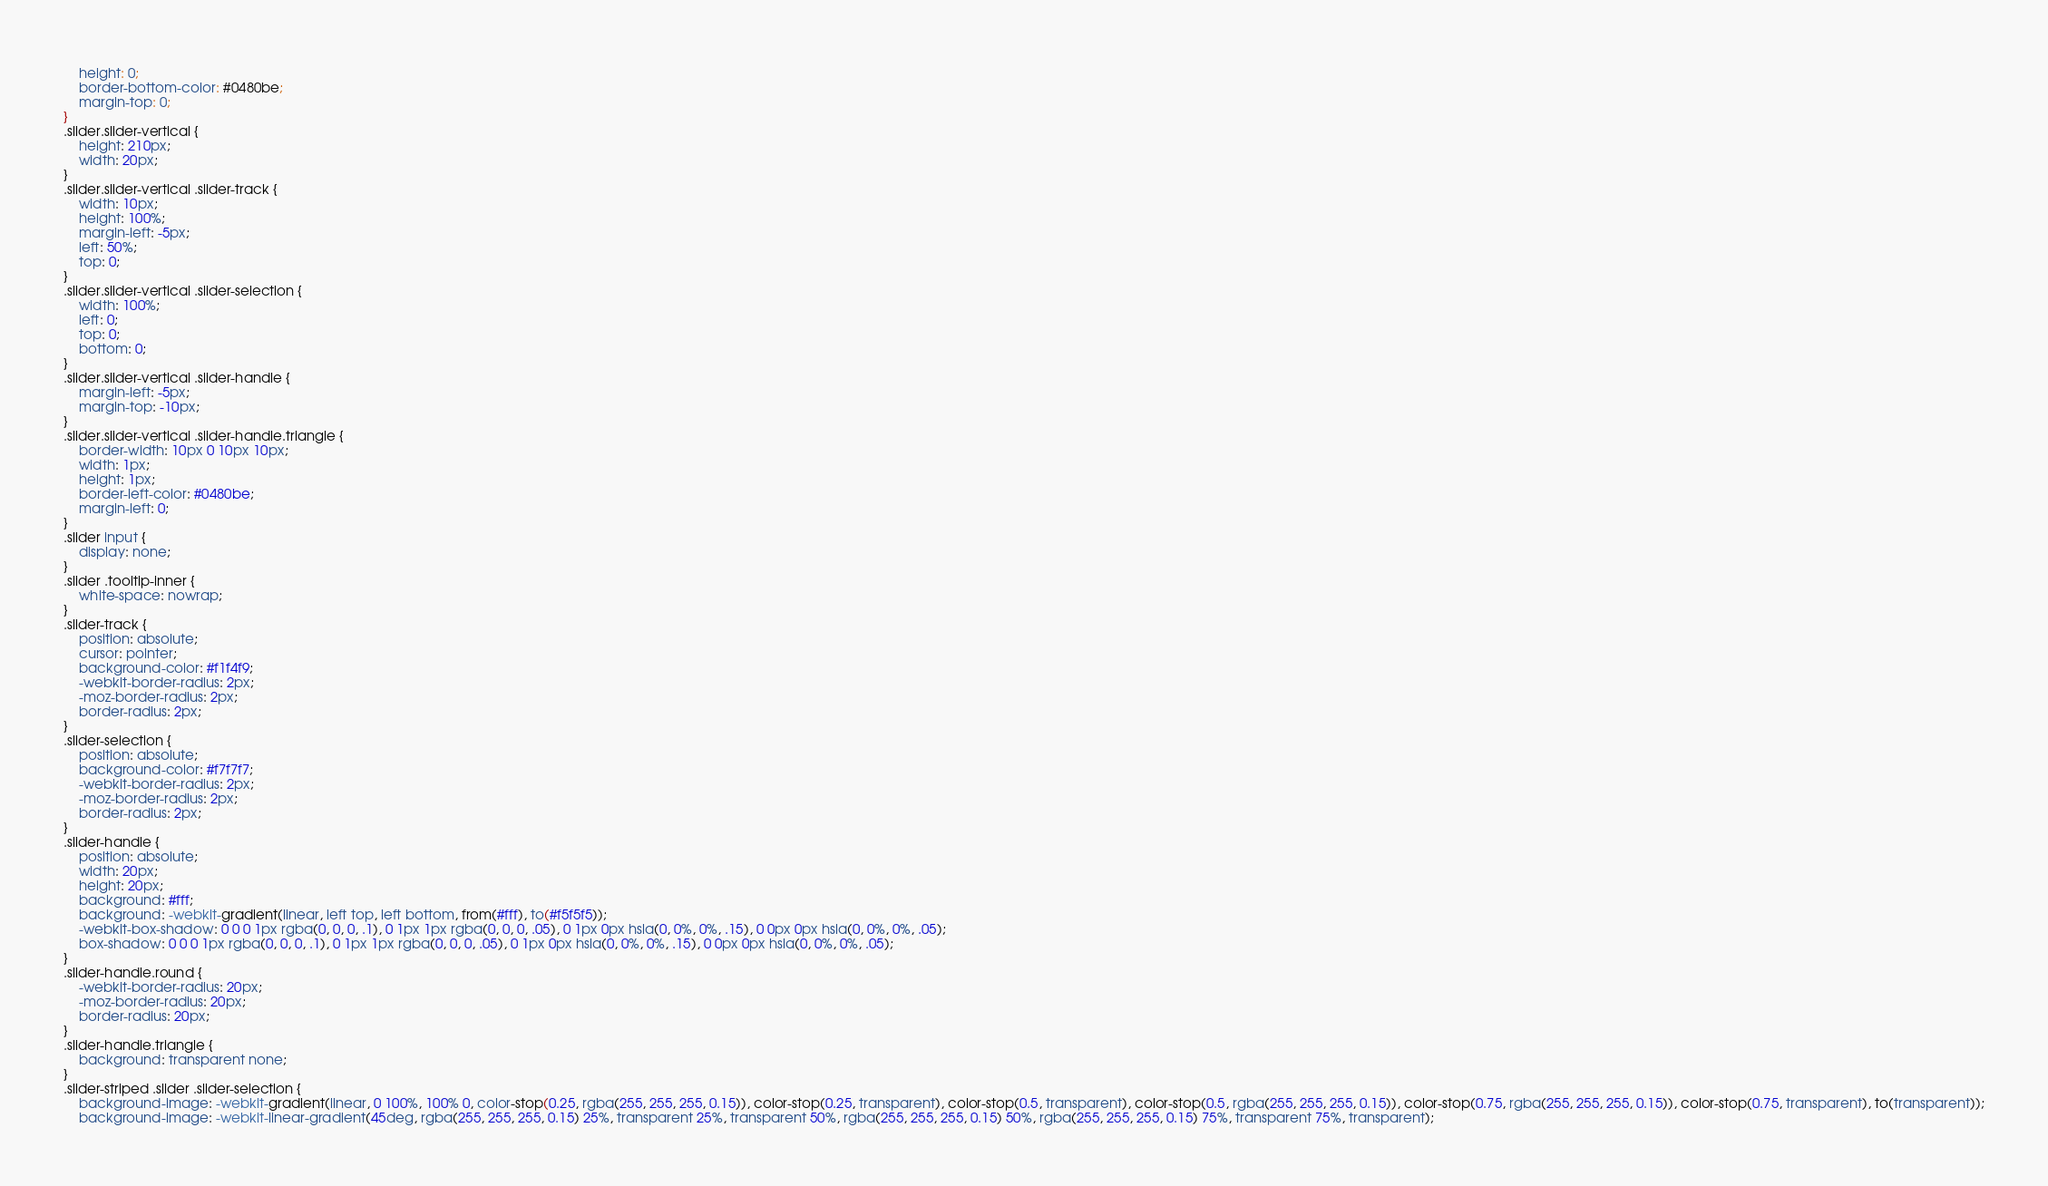<code> <loc_0><loc_0><loc_500><loc_500><_CSS_>    height: 0;
    border-bottom-color: #0480be;
    margin-top: 0;
}
.slider.slider-vertical {
    height: 210px;
    width: 20px;
}
.slider.slider-vertical .slider-track {
    width: 10px;
    height: 100%;
    margin-left: -5px;
    left: 50%;
    top: 0;
}
.slider.slider-vertical .slider-selection {
    width: 100%;
    left: 0;
    top: 0;
    bottom: 0;
}
.slider.slider-vertical .slider-handle {
    margin-left: -5px;
    margin-top: -10px;
}
.slider.slider-vertical .slider-handle.triangle {
    border-width: 10px 0 10px 10px;
    width: 1px;
    height: 1px;
    border-left-color: #0480be;
    margin-left: 0;
}
.slider input {
    display: none;
}
.slider .tooltip-inner {
    white-space: nowrap;
}
.slider-track {
    position: absolute;
    cursor: pointer;
    background-color: #f1f4f9;
    -webkit-border-radius: 2px;
    -moz-border-radius: 2px;
    border-radius: 2px;
}
.slider-selection {
    position: absolute;
    background-color: #f7f7f7;
    -webkit-border-radius: 2px;
    -moz-border-radius: 2px;
    border-radius: 2px;
}
.slider-handle {
    position: absolute;
    width: 20px;
    height: 20px;
    background: #fff;
    background: -webkit-gradient(linear, left top, left bottom, from(#fff), to(#f5f5f5));
    -webkit-box-shadow: 0 0 0 1px rgba(0, 0, 0, .1), 0 1px 1px rgba(0, 0, 0, .05), 0 1px 0px hsla(0, 0%, 0%, .15), 0 0px 0px hsla(0, 0%, 0%, .05);
    box-shadow: 0 0 0 1px rgba(0, 0, 0, .1), 0 1px 1px rgba(0, 0, 0, .05), 0 1px 0px hsla(0, 0%, 0%, .15), 0 0px 0px hsla(0, 0%, 0%, .05);
}
.slider-handle.round {
    -webkit-border-radius: 20px;
    -moz-border-radius: 20px;
    border-radius: 20px;
}
.slider-handle.triangle {
    background: transparent none;
}
.slider-striped .slider .slider-selection {
    background-image: -webkit-gradient(linear, 0 100%, 100% 0, color-stop(0.25, rgba(255, 255, 255, 0.15)), color-stop(0.25, transparent), color-stop(0.5, transparent), color-stop(0.5, rgba(255, 255, 255, 0.15)), color-stop(0.75, rgba(255, 255, 255, 0.15)), color-stop(0.75, transparent), to(transparent));
    background-image: -webkit-linear-gradient(45deg, rgba(255, 255, 255, 0.15) 25%, transparent 25%, transparent 50%, rgba(255, 255, 255, 0.15) 50%, rgba(255, 255, 255, 0.15) 75%, transparent 75%, transparent);</code> 